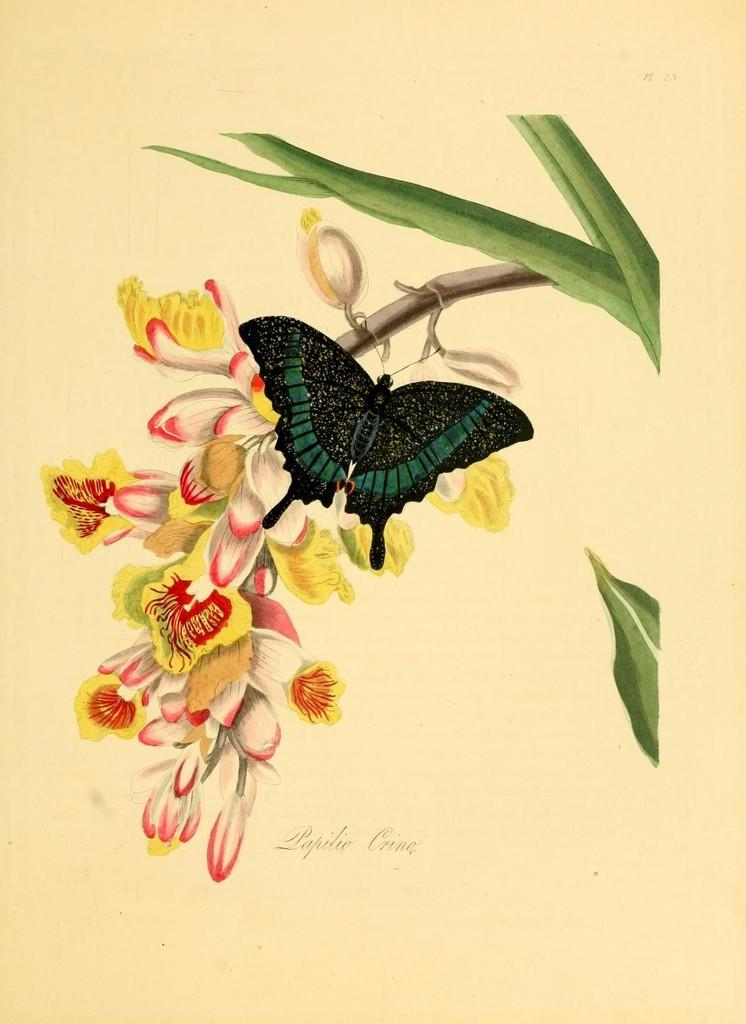What is depicted on the paper in the image? The paper contains a drawing of a tree branch. What elements are included in the drawing? The drawing includes a butterfly and flowers. What is the governor saying about the lumber in the image? There is no governor or lumber present in the image; it only contains a drawing of a tree branch, butterfly, and flowers. 